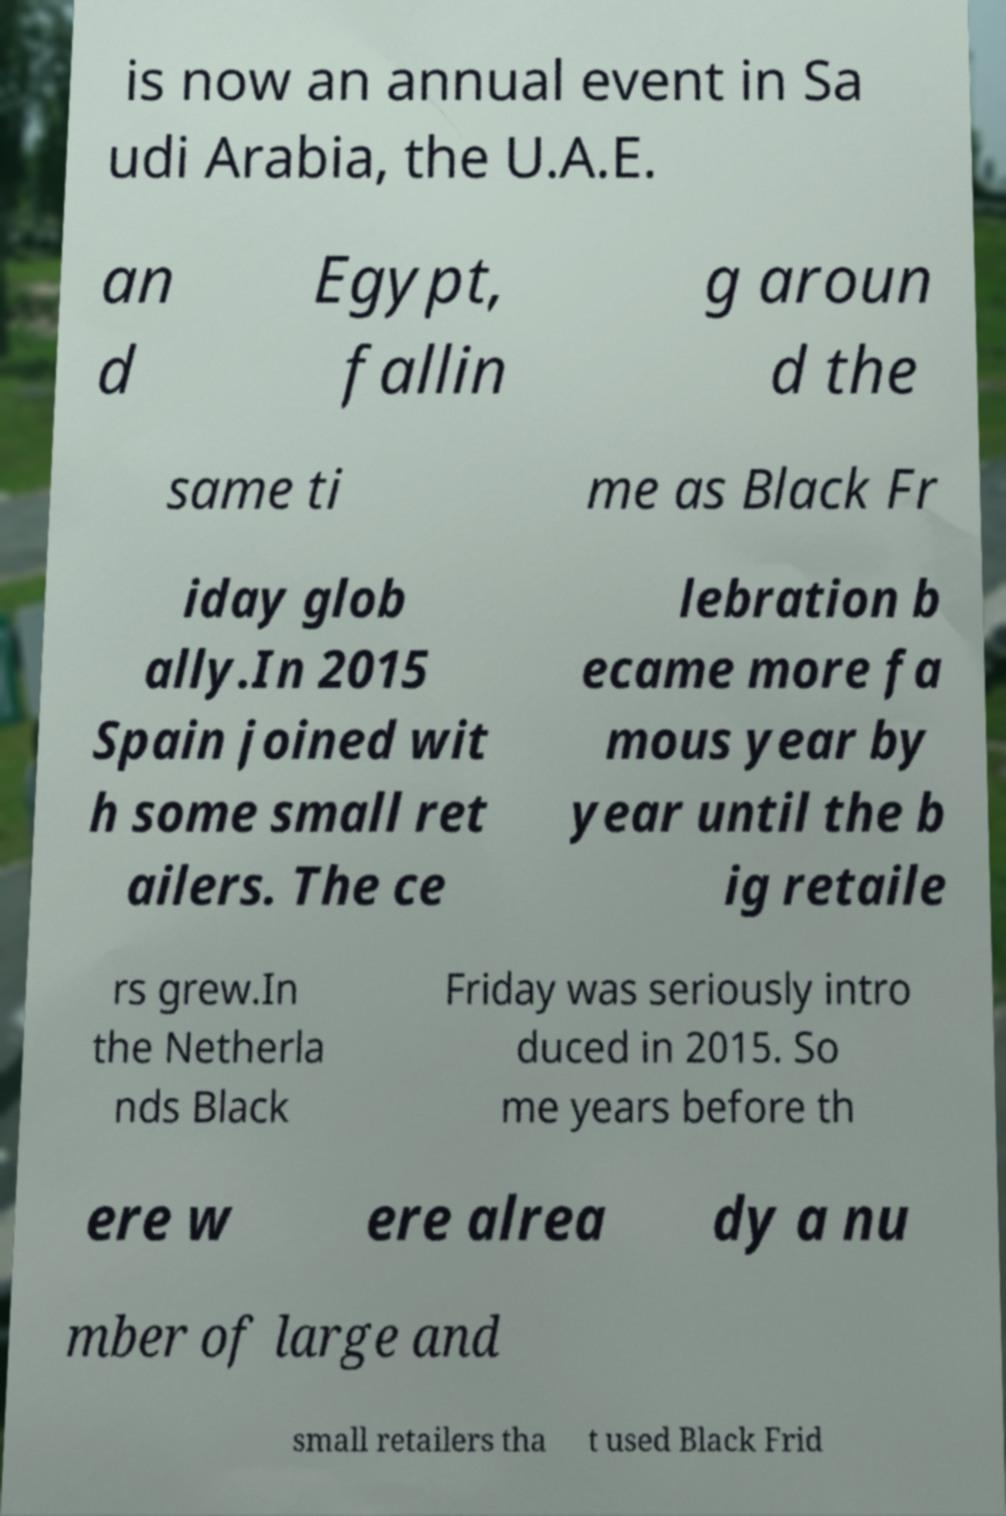What messages or text are displayed in this image? I need them in a readable, typed format. is now an annual event in Sa udi Arabia, the U.A.E. an d Egypt, fallin g aroun d the same ti me as Black Fr iday glob ally.In 2015 Spain joined wit h some small ret ailers. The ce lebration b ecame more fa mous year by year until the b ig retaile rs grew.In the Netherla nds Black Friday was seriously intro duced in 2015. So me years before th ere w ere alrea dy a nu mber of large and small retailers tha t used Black Frid 